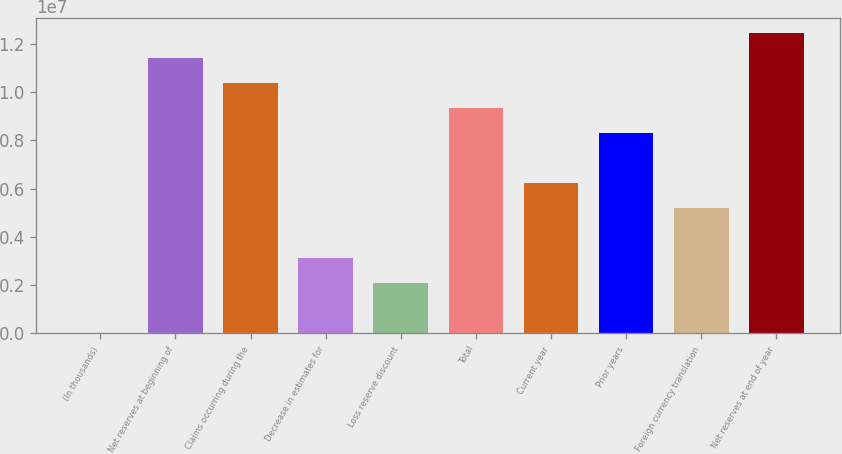Convert chart. <chart><loc_0><loc_0><loc_500><loc_500><bar_chart><fcel>(In thousands)<fcel>Net reserves at beginning of<fcel>Claims occurring during the<fcel>Decrease in estimates for<fcel>Loss reserve discount<fcel>Total<fcel>Current year<fcel>Prior years<fcel>Foreign currency translation<fcel>Net reserves at end of year<nl><fcel>2014<fcel>1.14065e+07<fcel>1.03697e+07<fcel>3.11232e+06<fcel>2.07555e+06<fcel>9.33293e+06<fcel>6.22263e+06<fcel>8.29616e+06<fcel>5.18586e+06<fcel>1.24432e+07<nl></chart> 